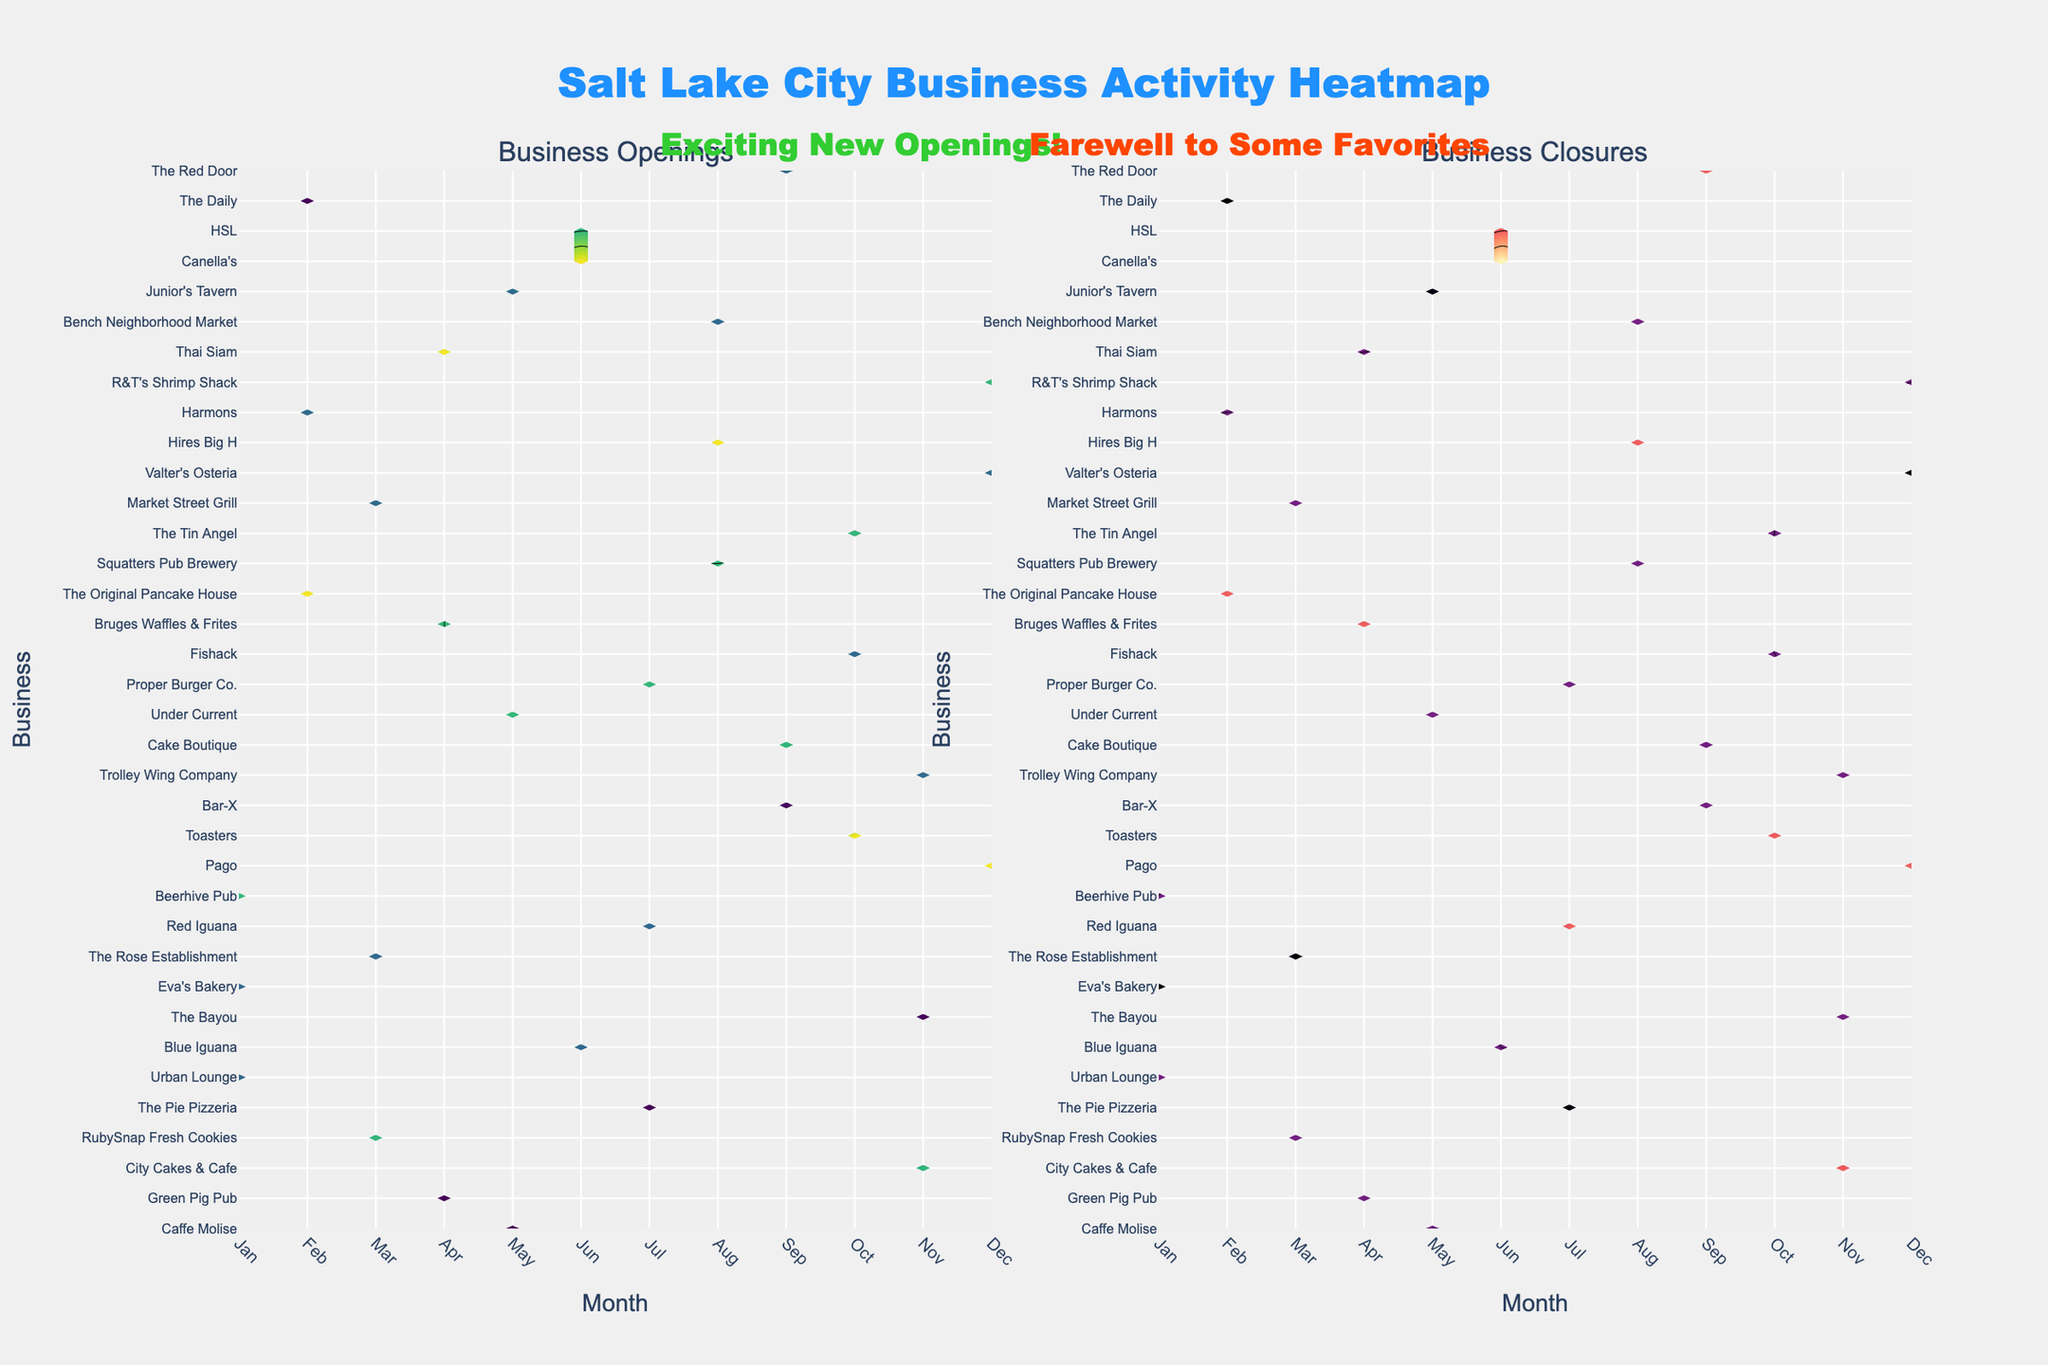What are the titles of the two subplots? The titles of the subplots are written at the top of each plot. The first subplot is titled "Business Openings" and the second subplot is titled "Business Closures".
Answer: Business Openings, Business Closures Which month appears to have the most business openings? Observe the heatmap on the "Business Openings" subplot. The month with the highest color intensity indicates the most business openings.
Answer: April Which business had the most closures in June? Look at the "Business Closures" subplot and find the business along the y-axis for June with the highest color intensity.
Answer: Trolley Wing Company Compare the contour plots, in which month did business closures outnumber openings the most? Compare the color intensities of the "Business Closures" and "Business Openings" subplots month by month to find the month where closures are significantly higher than openings.
Answer: June How many businesses had openings in January? Count the number of distinct businesses with any shade of color in the "Business Openings" subplot for January.
Answer: 3 What is the overall trend in business activity for August? Observe the color intensity in both subplots ("Business Openings" and "Business Closures") for August to determine if there's a balance, more openings, or more closures.
Answer: Balanced with more openings Which business had notable activity (either opening or closing) consistently throughout multiple months? Look at both subplots and identify the business with a consistent color intensity along y-axis across several months.
Answer: The Original Pancake House From the heatmaps, what can you infer about the business activity at the end of the year in December? Analyze the color intensity in both subplots for December month to determine the business activity in terms of both openings and closures.
Answer: High openings, moderate closures In what way do the contours of "Business Openings" and "Business Closures" differ in February? Compare the color density pattern of both subplots specifically for the month of February to see the difference.
Answer: More openings than closures Which business seems to be most resilient with fewer closures across all months? In the "Business Closures" subplot, find the business with the least or no color intensity spread across the months indicating fewer closures.
Answer: City Cakes & Cafe 